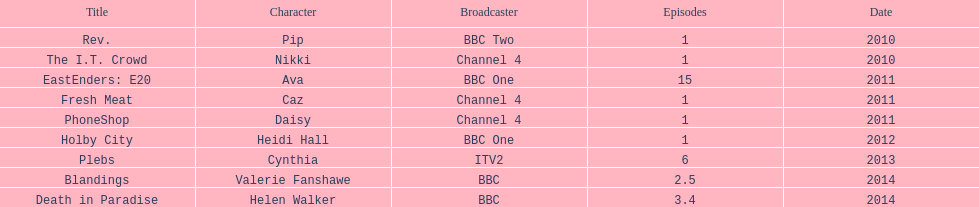What is the only role she played with broadcaster itv2? Cynthia. Parse the table in full. {'header': ['Title', 'Character', 'Broadcaster', 'Episodes', 'Date'], 'rows': [['Rev.', 'Pip', 'BBC Two', '1', '2010'], ['The I.T. Crowd', 'Nikki', 'Channel 4', '1', '2010'], ['EastEnders: E20', 'Ava', 'BBC One', '15', '2011'], ['Fresh Meat', 'Caz', 'Channel 4', '1', '2011'], ['PhoneShop', 'Daisy', 'Channel 4', '1', '2011'], ['Holby City', 'Heidi Hall', 'BBC One', '1', '2012'], ['Plebs', 'Cynthia', 'ITV2', '6', '2013'], ['Blandings', 'Valerie Fanshawe', 'BBC', '2.5', '2014'], ['Death in Paradise', 'Helen Walker', 'BBC', '3.4', '2014']]} 